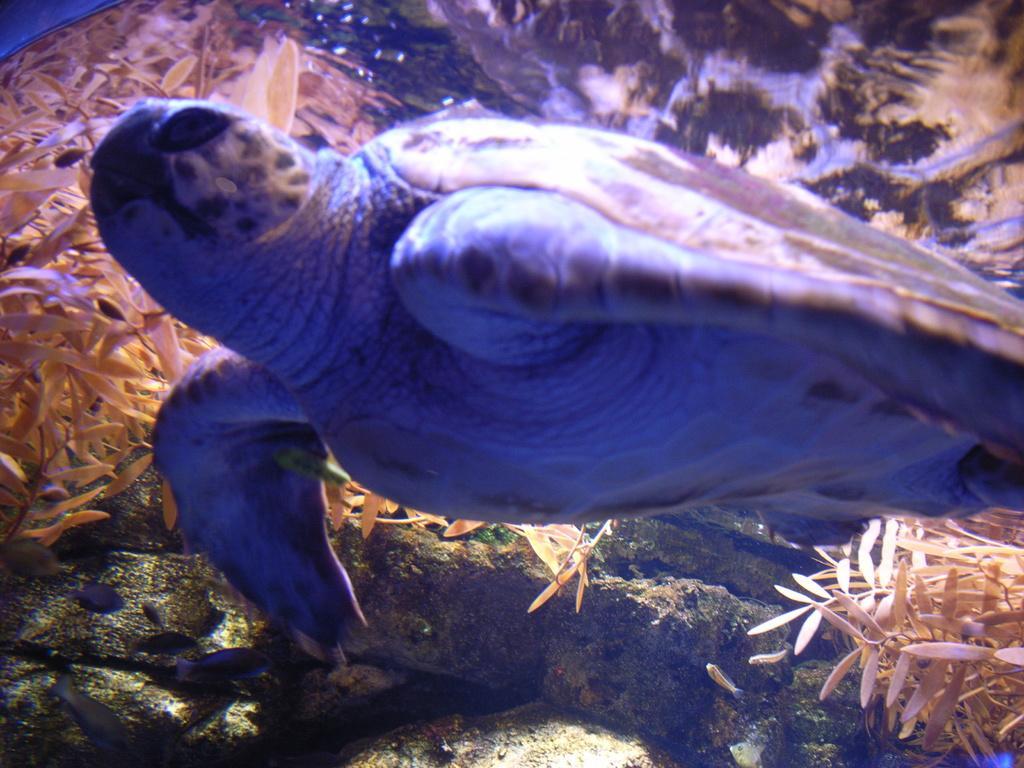Please provide a concise description of this image. In the picture we can see turtle which is under water and we can see some aquatic plants. 